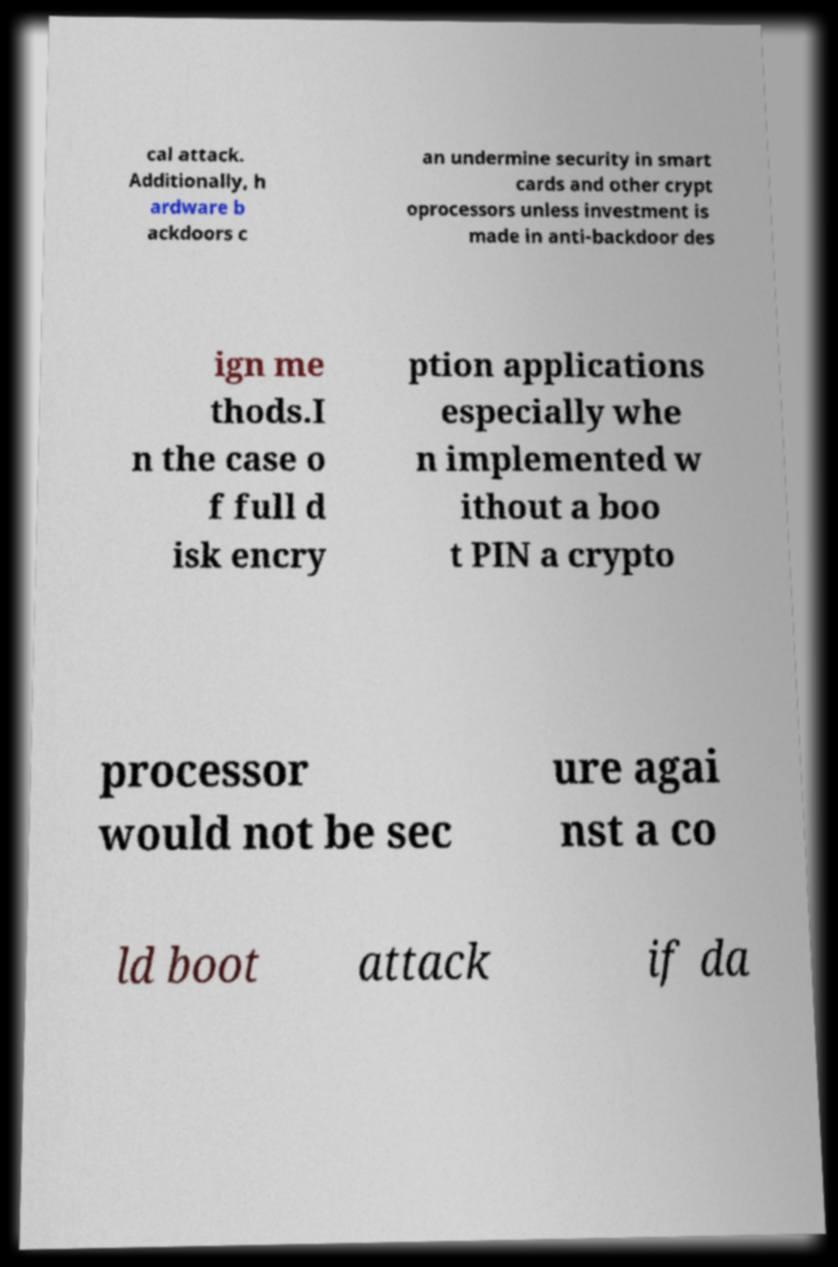I need the written content from this picture converted into text. Can you do that? cal attack. Additionally, h ardware b ackdoors c an undermine security in smart cards and other crypt oprocessors unless investment is made in anti-backdoor des ign me thods.I n the case o f full d isk encry ption applications especially whe n implemented w ithout a boo t PIN a crypto processor would not be sec ure agai nst a co ld boot attack if da 